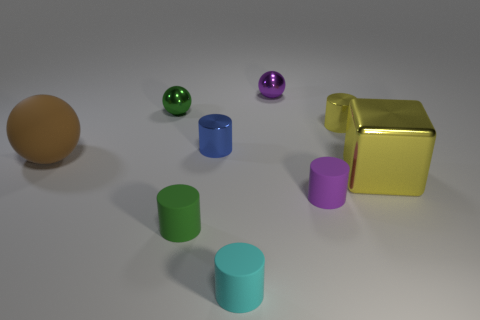Do the green metal object and the blue object have the same shape?
Give a very brief answer. No. What number of objects are behind the small green ball and in front of the small purple metallic thing?
Your answer should be very brief. 0. How many metallic things are either brown spheres or small cylinders?
Provide a short and direct response. 2. There is a green thing in front of the object right of the small yellow cylinder; what size is it?
Your response must be concise. Small. What is the material of the small thing that is the same color as the metallic cube?
Keep it short and to the point. Metal. Is there a small rubber cylinder that is behind the purple matte cylinder to the right of the tiny purple thing behind the brown rubber ball?
Keep it short and to the point. No. Do the tiny green thing that is behind the small yellow metal cylinder and the sphere right of the tiny cyan matte thing have the same material?
Your response must be concise. Yes. How many things are large cyan rubber blocks or matte objects behind the tiny purple rubber thing?
Offer a terse response. 1. How many cyan objects are the same shape as the large brown rubber thing?
Offer a very short reply. 0. What is the material of the cyan cylinder that is the same size as the purple ball?
Provide a short and direct response. Rubber. 